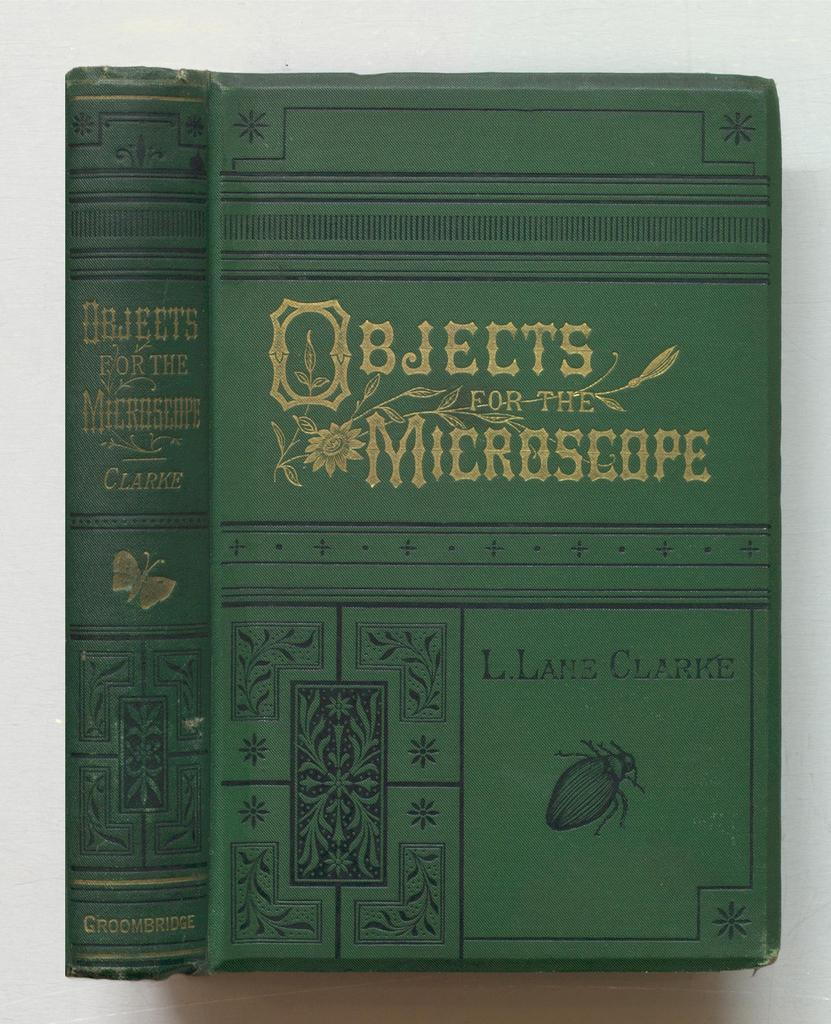<image>
Render a clear and concise summary of the photo. a copy of the book obbjects for the microscope written by L. Lane Clarke. 